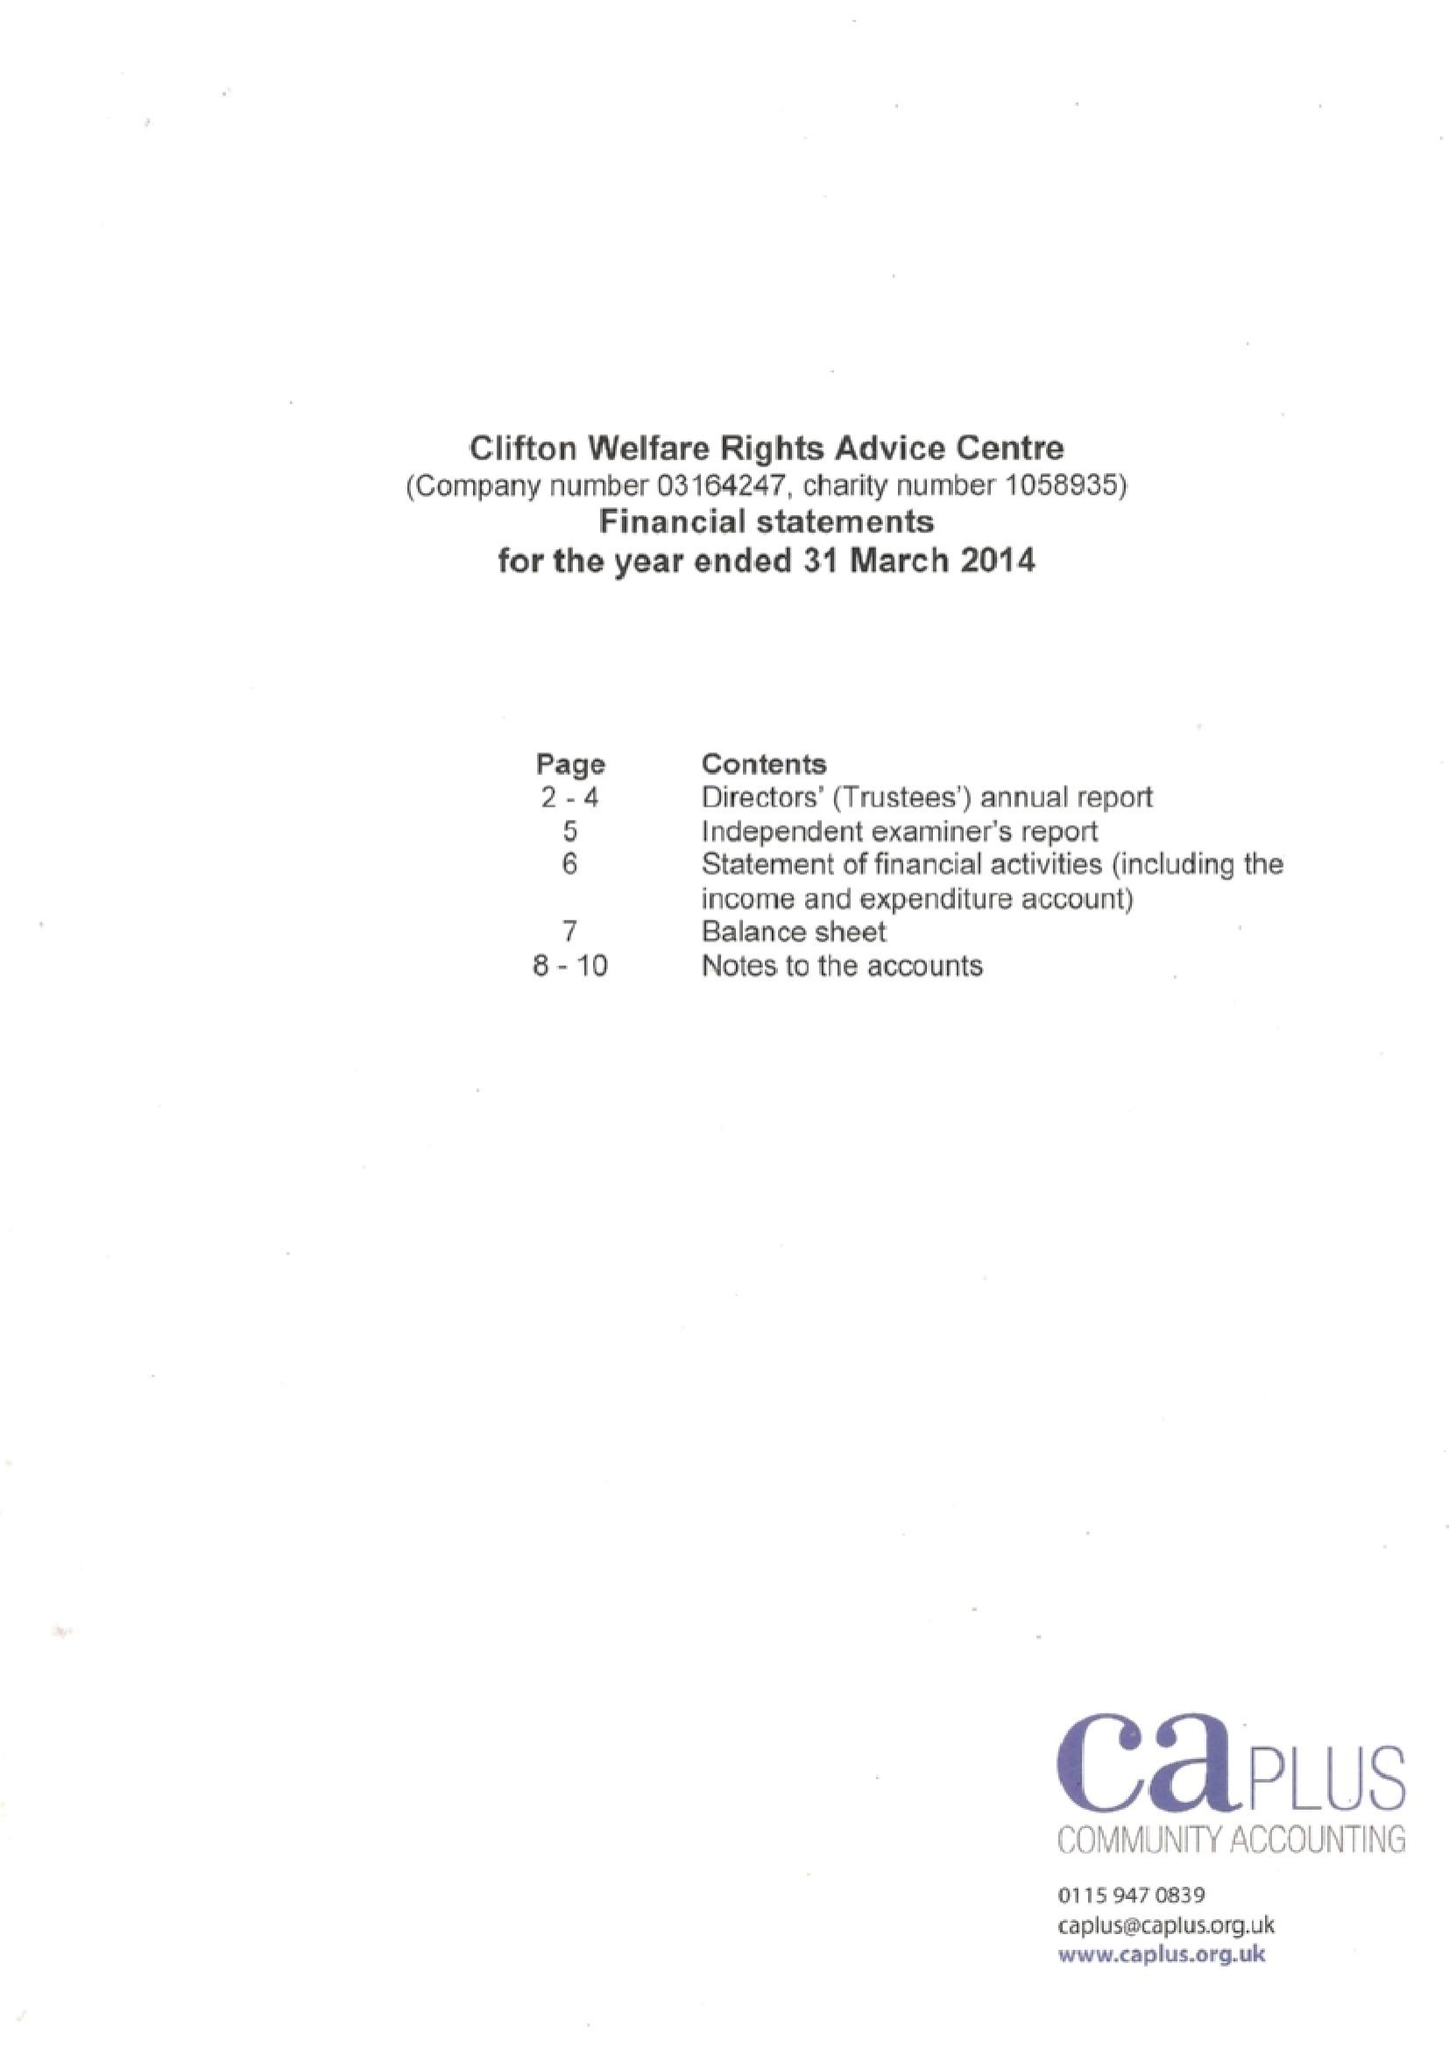What is the value for the address__post_town?
Answer the question using a single word or phrase. NOTTINGHAM 